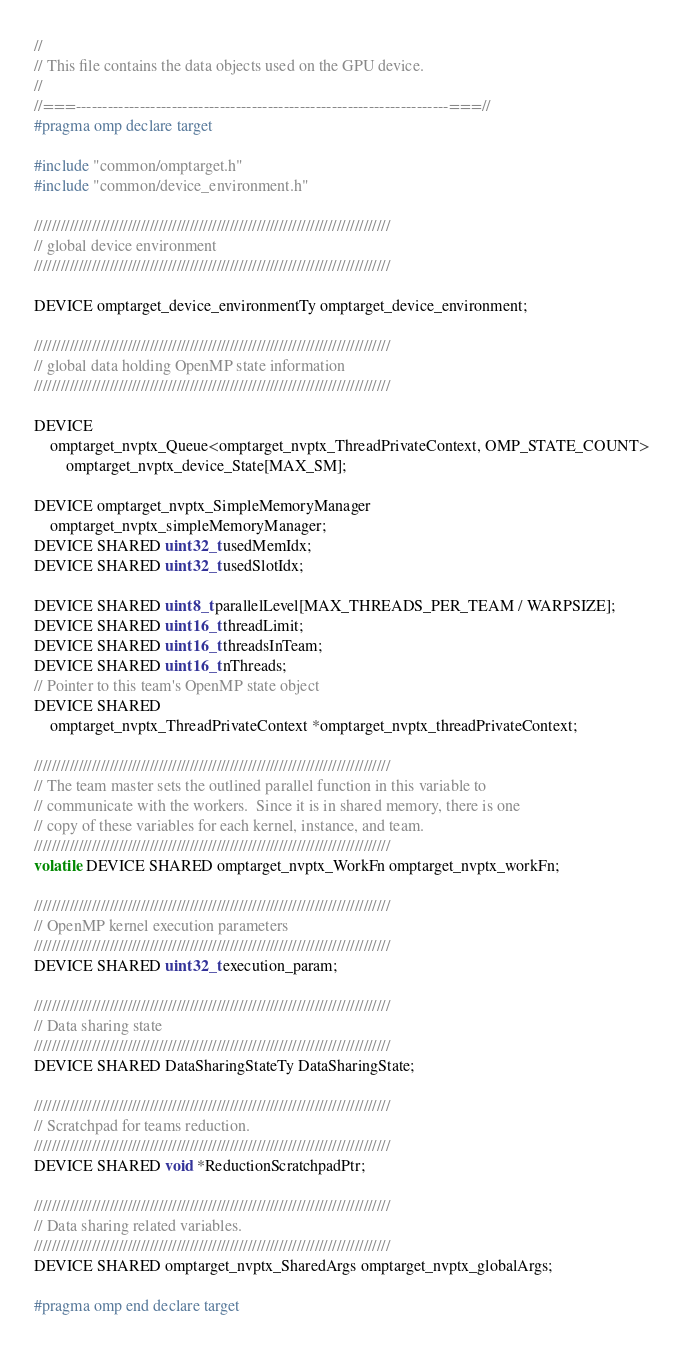Convert code to text. <code><loc_0><loc_0><loc_500><loc_500><_Cuda_>//
// This file contains the data objects used on the GPU device.
//
//===----------------------------------------------------------------------===//
#pragma omp declare target

#include "common/omptarget.h"
#include "common/device_environment.h"

////////////////////////////////////////////////////////////////////////////////
// global device environment
////////////////////////////////////////////////////////////////////////////////

DEVICE omptarget_device_environmentTy omptarget_device_environment;

////////////////////////////////////////////////////////////////////////////////
// global data holding OpenMP state information
////////////////////////////////////////////////////////////////////////////////

DEVICE
    omptarget_nvptx_Queue<omptarget_nvptx_ThreadPrivateContext, OMP_STATE_COUNT>
        omptarget_nvptx_device_State[MAX_SM];

DEVICE omptarget_nvptx_SimpleMemoryManager
    omptarget_nvptx_simpleMemoryManager;
DEVICE SHARED uint32_t usedMemIdx;
DEVICE SHARED uint32_t usedSlotIdx;

DEVICE SHARED uint8_t parallelLevel[MAX_THREADS_PER_TEAM / WARPSIZE];
DEVICE SHARED uint16_t threadLimit;
DEVICE SHARED uint16_t threadsInTeam;
DEVICE SHARED uint16_t nThreads;
// Pointer to this team's OpenMP state object
DEVICE SHARED
    omptarget_nvptx_ThreadPrivateContext *omptarget_nvptx_threadPrivateContext;

////////////////////////////////////////////////////////////////////////////////
// The team master sets the outlined parallel function in this variable to
// communicate with the workers.  Since it is in shared memory, there is one
// copy of these variables for each kernel, instance, and team.
////////////////////////////////////////////////////////////////////////////////
volatile DEVICE SHARED omptarget_nvptx_WorkFn omptarget_nvptx_workFn;

////////////////////////////////////////////////////////////////////////////////
// OpenMP kernel execution parameters
////////////////////////////////////////////////////////////////////////////////
DEVICE SHARED uint32_t execution_param;

////////////////////////////////////////////////////////////////////////////////
// Data sharing state
////////////////////////////////////////////////////////////////////////////////
DEVICE SHARED DataSharingStateTy DataSharingState;

////////////////////////////////////////////////////////////////////////////////
// Scratchpad for teams reduction.
////////////////////////////////////////////////////////////////////////////////
DEVICE SHARED void *ReductionScratchpadPtr;

////////////////////////////////////////////////////////////////////////////////
// Data sharing related variables.
////////////////////////////////////////////////////////////////////////////////
DEVICE SHARED omptarget_nvptx_SharedArgs omptarget_nvptx_globalArgs;

#pragma omp end declare target
</code> 